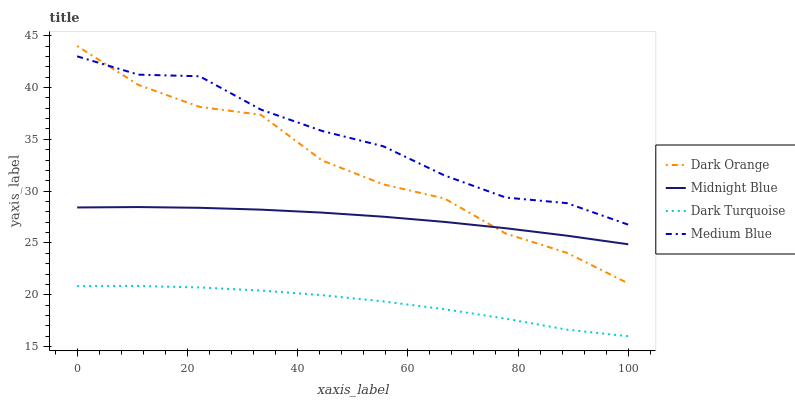Does Dark Turquoise have the minimum area under the curve?
Answer yes or no. Yes. Does Medium Blue have the maximum area under the curve?
Answer yes or no. Yes. Does Midnight Blue have the minimum area under the curve?
Answer yes or no. No. Does Midnight Blue have the maximum area under the curve?
Answer yes or no. No. Is Midnight Blue the smoothest?
Answer yes or no. Yes. Is Dark Orange the roughest?
Answer yes or no. Yes. Is Medium Blue the smoothest?
Answer yes or no. No. Is Medium Blue the roughest?
Answer yes or no. No. Does Dark Turquoise have the lowest value?
Answer yes or no. Yes. Does Midnight Blue have the lowest value?
Answer yes or no. No. Does Dark Orange have the highest value?
Answer yes or no. Yes. Does Medium Blue have the highest value?
Answer yes or no. No. Is Midnight Blue less than Medium Blue?
Answer yes or no. Yes. Is Medium Blue greater than Midnight Blue?
Answer yes or no. Yes. Does Medium Blue intersect Dark Orange?
Answer yes or no. Yes. Is Medium Blue less than Dark Orange?
Answer yes or no. No. Is Medium Blue greater than Dark Orange?
Answer yes or no. No. Does Midnight Blue intersect Medium Blue?
Answer yes or no. No. 